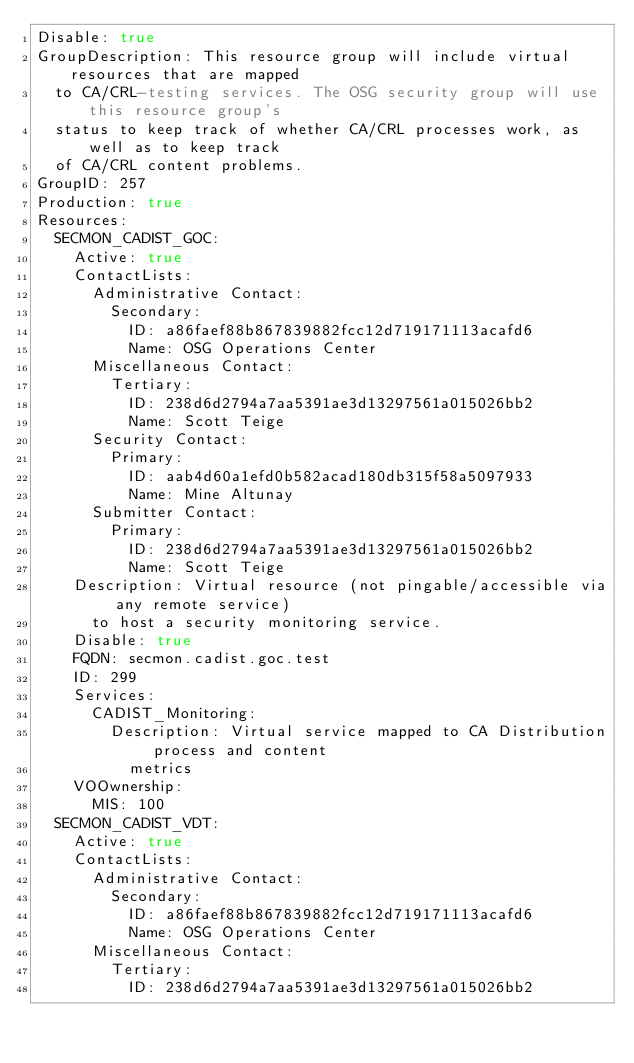Convert code to text. <code><loc_0><loc_0><loc_500><loc_500><_YAML_>Disable: true
GroupDescription: This resource group will include virtual resources that are mapped
  to CA/CRL-testing services. The OSG security group will use this resource group's
  status to keep track of whether CA/CRL processes work, as well as to keep track
  of CA/CRL content problems.
GroupID: 257
Production: true
Resources:
  SECMON_CADIST_GOC:
    Active: true
    ContactLists:
      Administrative Contact:
        Secondary:
          ID: a86faef88b867839882fcc12d719171113acafd6
          Name: OSG Operations Center
      Miscellaneous Contact:
        Tertiary:
          ID: 238d6d2794a7aa5391ae3d13297561a015026bb2
          Name: Scott Teige
      Security Contact:
        Primary:
          ID: aab4d60a1efd0b582acad180db315f58a5097933
          Name: Mine Altunay
      Submitter Contact:
        Primary:
          ID: 238d6d2794a7aa5391ae3d13297561a015026bb2
          Name: Scott Teige
    Description: Virtual resource (not pingable/accessible via any remote service)
      to host a security monitoring service.
    Disable: true
    FQDN: secmon.cadist.goc.test
    ID: 299
    Services:
      CADIST_Monitoring:
        Description: Virtual service mapped to CA Distribution process and content
          metrics
    VOOwnership:
      MIS: 100
  SECMON_CADIST_VDT:
    Active: true
    ContactLists:
      Administrative Contact:
        Secondary:
          ID: a86faef88b867839882fcc12d719171113acafd6
          Name: OSG Operations Center
      Miscellaneous Contact:
        Tertiary:
          ID: 238d6d2794a7aa5391ae3d13297561a015026bb2</code> 